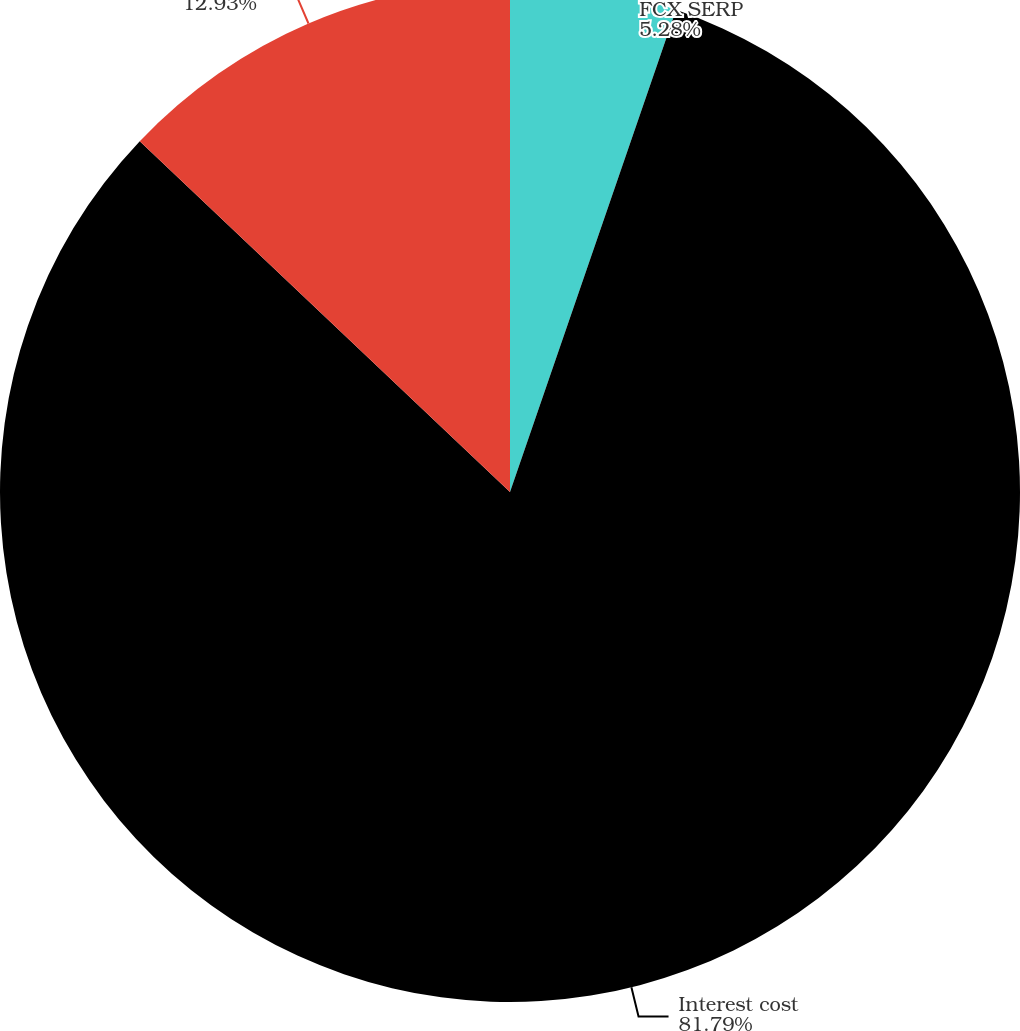Convert chart. <chart><loc_0><loc_0><loc_500><loc_500><pie_chart><fcel>FCX SERP<fcel>Interest cost<fcel>Amortization of prior service<nl><fcel>5.28%<fcel>81.79%<fcel>12.93%<nl></chart> 